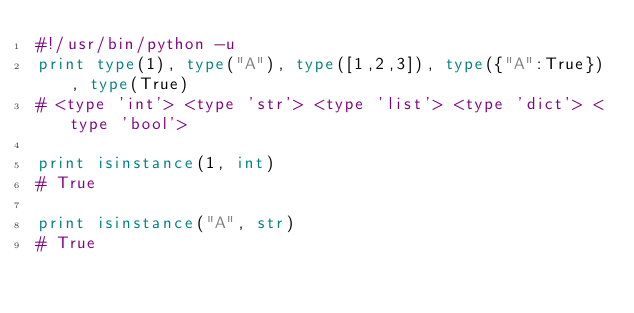Convert code to text. <code><loc_0><loc_0><loc_500><loc_500><_Python_>#!/usr/bin/python -u
print type(1), type("A"), type([1,2,3]), type({"A":True}), type(True)
# <type 'int'> <type 'str'> <type 'list'> <type 'dict'> <type 'bool'>

print isinstance(1, int)
# True

print isinstance("A", str)
# True

</code> 